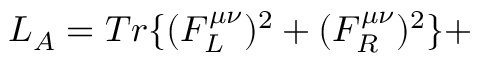Convert formula to latex. <formula><loc_0><loc_0><loc_500><loc_500>L _ { A } = T r \{ ( F _ { L } ^ { \mu \nu } ) ^ { 2 } + ( F _ { R } ^ { \mu \nu } ) ^ { 2 } \} +</formula> 